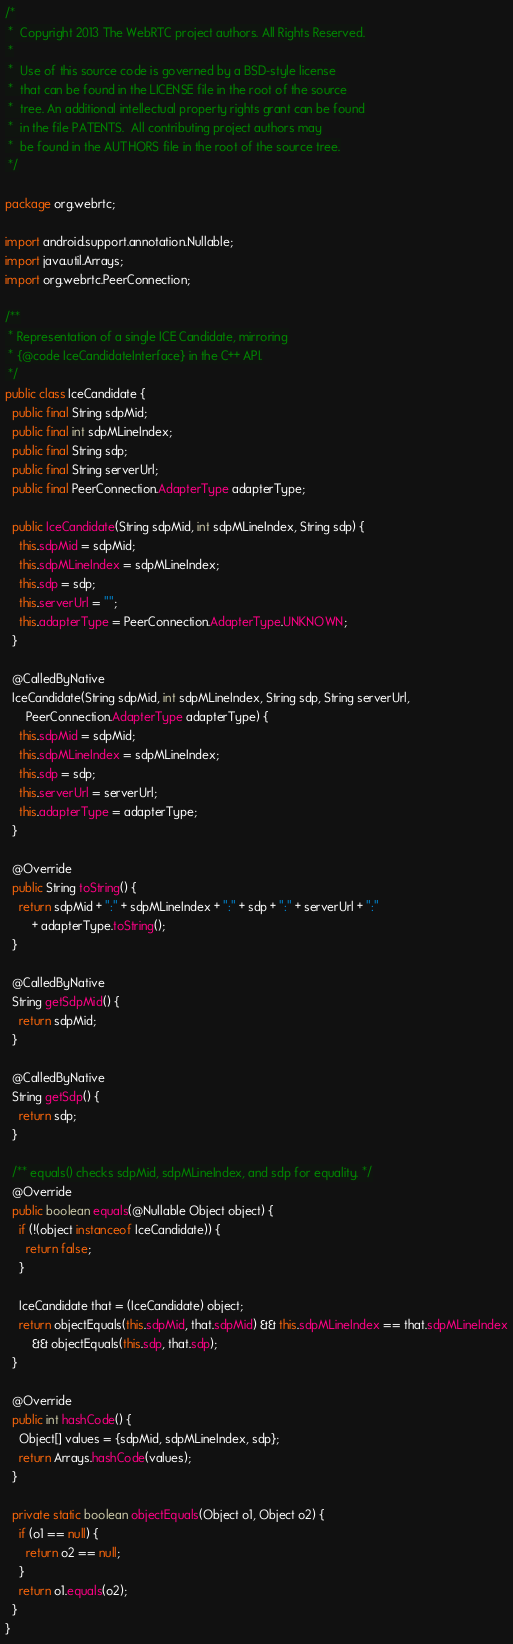<code> <loc_0><loc_0><loc_500><loc_500><_Java_>/*
 *  Copyright 2013 The WebRTC project authors. All Rights Reserved.
 *
 *  Use of this source code is governed by a BSD-style license
 *  that can be found in the LICENSE file in the root of the source
 *  tree. An additional intellectual property rights grant can be found
 *  in the file PATENTS.  All contributing project authors may
 *  be found in the AUTHORS file in the root of the source tree.
 */

package org.webrtc;

import android.support.annotation.Nullable;
import java.util.Arrays;
import org.webrtc.PeerConnection;

/**
 * Representation of a single ICE Candidate, mirroring
 * {@code IceCandidateInterface} in the C++ API.
 */
public class IceCandidate {
  public final String sdpMid;
  public final int sdpMLineIndex;
  public final String sdp;
  public final String serverUrl;
  public final PeerConnection.AdapterType adapterType;

  public IceCandidate(String sdpMid, int sdpMLineIndex, String sdp) {
    this.sdpMid = sdpMid;
    this.sdpMLineIndex = sdpMLineIndex;
    this.sdp = sdp;
    this.serverUrl = "";
    this.adapterType = PeerConnection.AdapterType.UNKNOWN;
  }

  @CalledByNative
  IceCandidate(String sdpMid, int sdpMLineIndex, String sdp, String serverUrl,
      PeerConnection.AdapterType adapterType) {
    this.sdpMid = sdpMid;
    this.sdpMLineIndex = sdpMLineIndex;
    this.sdp = sdp;
    this.serverUrl = serverUrl;
    this.adapterType = adapterType;
  }

  @Override
  public String toString() {
    return sdpMid + ":" + sdpMLineIndex + ":" + sdp + ":" + serverUrl + ":"
        + adapterType.toString();
  }

  @CalledByNative
  String getSdpMid() {
    return sdpMid;
  }

  @CalledByNative
  String getSdp() {
    return sdp;
  }

  /** equals() checks sdpMid, sdpMLineIndex, and sdp for equality. */
  @Override
  public boolean equals(@Nullable Object object) {
    if (!(object instanceof IceCandidate)) {
      return false;
    }

    IceCandidate that = (IceCandidate) object;
    return objectEquals(this.sdpMid, that.sdpMid) && this.sdpMLineIndex == that.sdpMLineIndex
        && objectEquals(this.sdp, that.sdp);
  }

  @Override
  public int hashCode() {
    Object[] values = {sdpMid, sdpMLineIndex, sdp};
    return Arrays.hashCode(values);
  }

  private static boolean objectEquals(Object o1, Object o2) {
    if (o1 == null) {
      return o2 == null;
    }
    return o1.equals(o2);
  }
}
</code> 